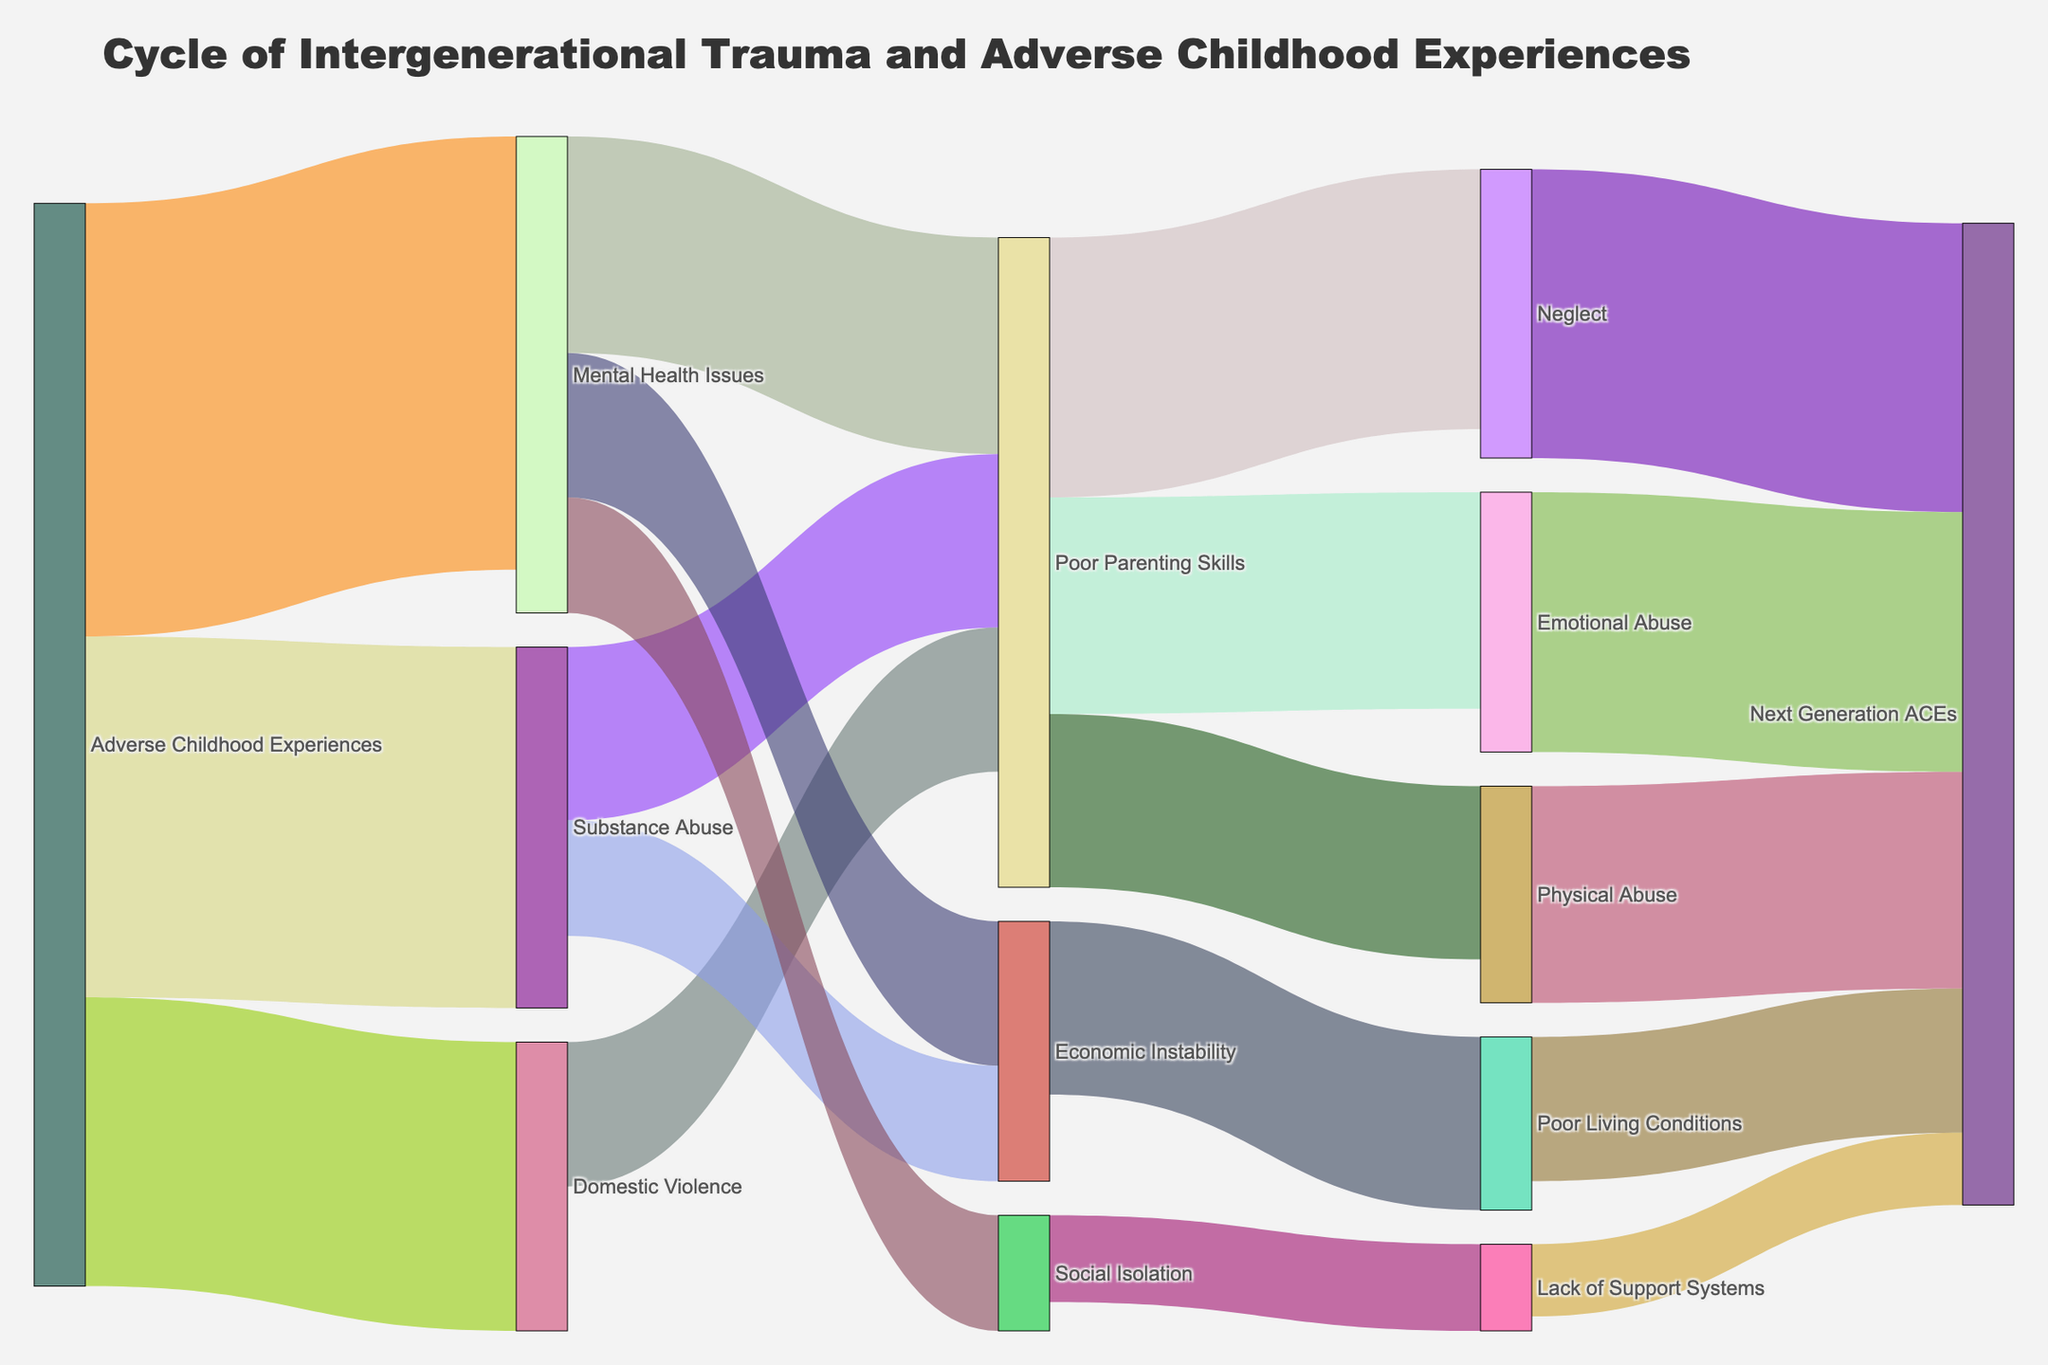How many main sources of factors are there in the diagram? Count the distinct sources in the Sankey diagram; Adverse Childhood Experiences, Mental Health Issues, Substance Abuse, Domestic Violence, Poor Parenting Skills, Neglect, Emotional Abuse, Physical Abuse, Economic Instability, Social Isolation, Lack of Support Systems
Answer: 11 What is the title of the Sankey diagram? Look at the title text present above the Sankey diagram
Answer: Cycle of Intergenerational Trauma and Adverse Childhood Experiences Which factor has the highest value flowing into 'Poor Parenting Skills'? Compare the values of links flowing into 'Poor Parenting Skills' from Mental Health Issues, Substance Abuse, and Domestic Violence. The values are 15, 12, and 10 respectively.
Answer: Mental Health Issues How many connections contribute to the 'Next Generation ACEs'? Count all the links in the diagram that end with 'Next Generation ACEs'. The links come from Neglect, Emotional Abuse, Physical Abuse, Poor Living Conditions, and Lack of Support Systems.
Answer: 5 What is the combined value of 'Economic Instability' impacts? Sum the values of links stemming from Economic Instability, which include Poor Living Conditions and Social Isolation. The values are 12 and 10 respectively.
Answer: 22 Which has a higher value: 'Substance Abuse' contributing to 'Economic Instability' or 'Substance Abuse' contributing to 'Poor Parenting Skills'? Compare the values of the links from Substance Abuse to Economic Instability and Poor Parenting Skills. The values are 8 and 12 respectively.
Answer: Poor Parenting Skills What proportion of ACEs contribute to Mental Health Issues versus Substance Abuse? Calculate the total contribution of ACEs to these impacts; 30 for Mental Health Issues and 25 for Substance Abuse. The total is 30 + 25 = 55. So, the proportion for Mental Health Issues is 30/55 and for Substance Abuse is 25/55.
Answer: (Mental Health Issues: approximately 55%, Substance Abuse: approximately 45%) Which connection has the highest value flowing directly into 'Next Generation ACEs'? Evaluate the values of the links directly flowing into 'Next Generation ACEs' from Neglect, Emotional Abuse, Physical Abuse, Poor Living Conditions, and Lack of Support Systems. The values are 20, 18, 15, 10, and 5 respectively.
Answer: Neglect 